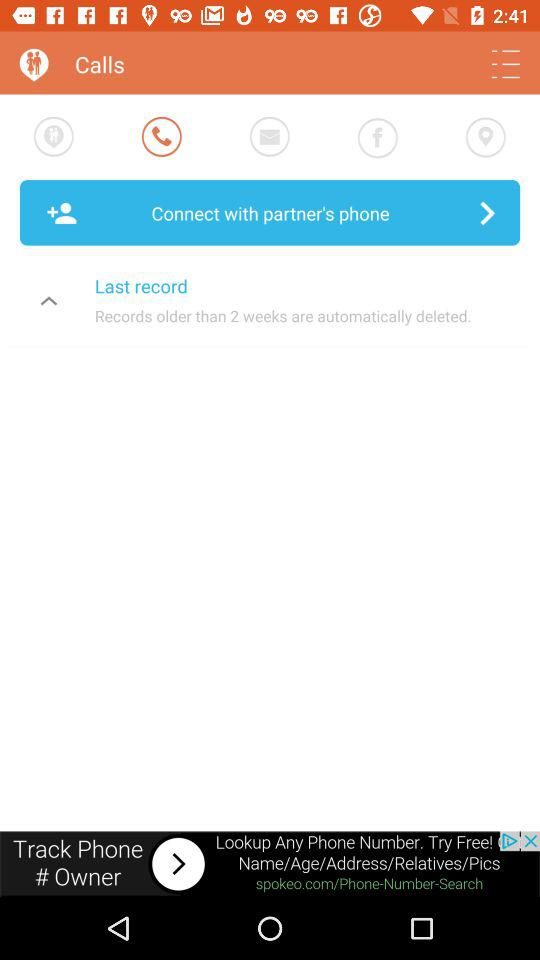How many days are older records deleted after?
Answer the question using a single word or phrase. 2 weeks 